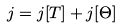<formula> <loc_0><loc_0><loc_500><loc_500>j = j [ T ] + j [ \Theta ]</formula> 